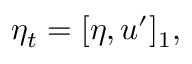Convert formula to latex. <formula><loc_0><loc_0><loc_500><loc_500>\eta _ { t } = [ \eta , u ^ { \prime } ] _ { 1 } ,</formula> 